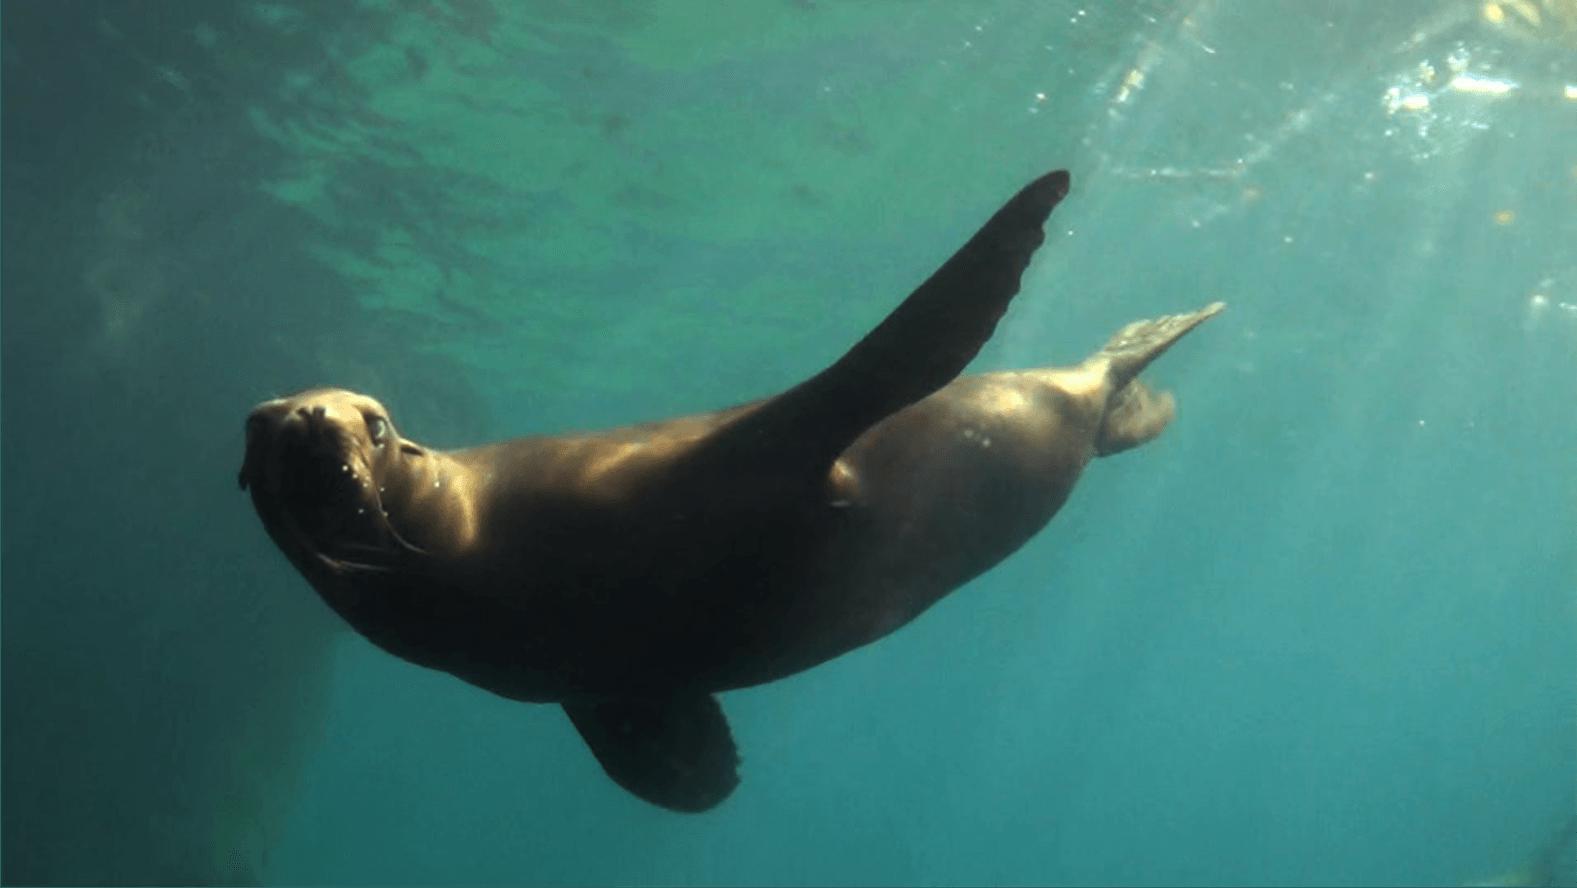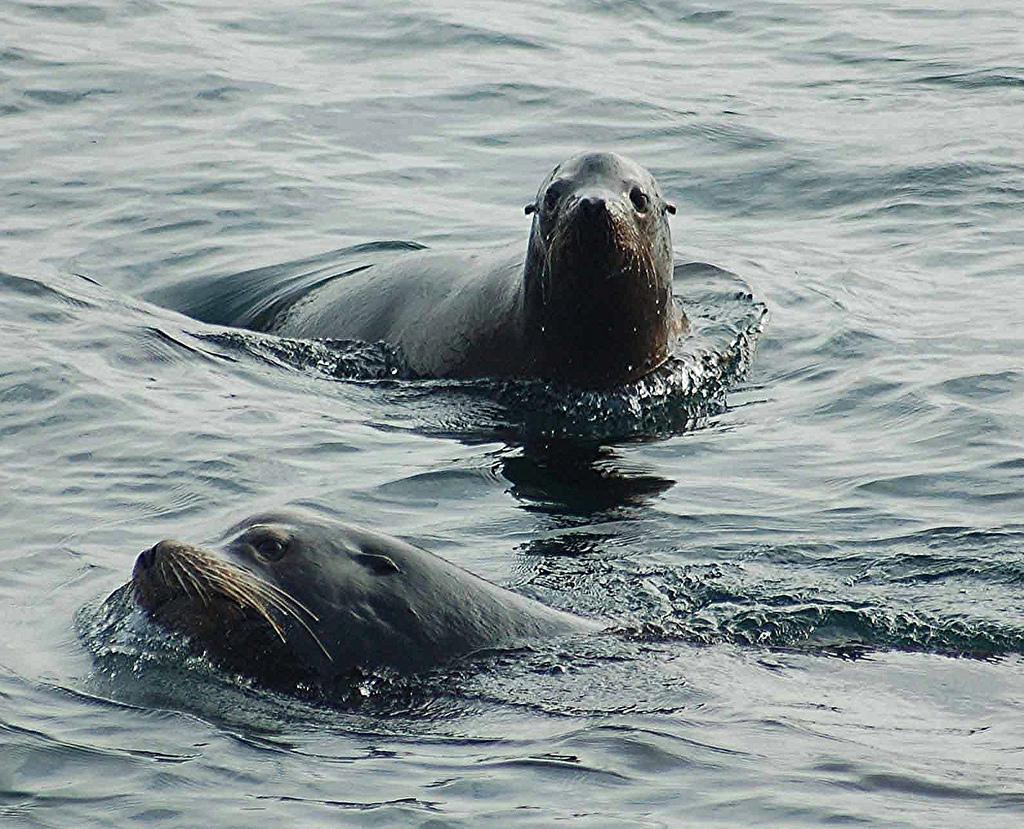The first image is the image on the left, the second image is the image on the right. Considering the images on both sides, is "There are at least eight sea lions in total." valid? Answer yes or no. No. The first image is the image on the left, the second image is the image on the right. Evaluate the accuracy of this statement regarding the images: "One of the images shows the surface of the ocean with at least two otters popping their heads out of the water.". Is it true? Answer yes or no. Yes. 